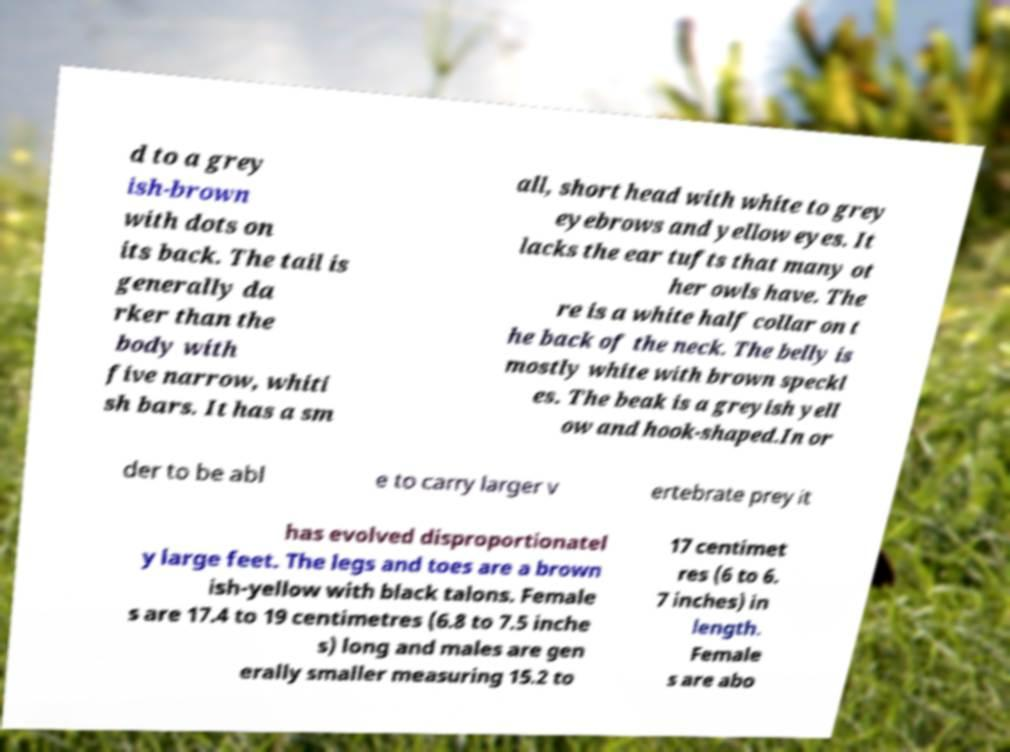There's text embedded in this image that I need extracted. Can you transcribe it verbatim? d to a grey ish-brown with dots on its back. The tail is generally da rker than the body with five narrow, whiti sh bars. It has a sm all, short head with white to grey eyebrows and yellow eyes. It lacks the ear tufts that many ot her owls have. The re is a white half collar on t he back of the neck. The belly is mostly white with brown speckl es. The beak is a greyish yell ow and hook-shaped.In or der to be abl e to carry larger v ertebrate prey it has evolved disproportionatel y large feet. The legs and toes are a brown ish-yellow with black talons. Female s are 17.4 to 19 centimetres (6.8 to 7.5 inche s) long and males are gen erally smaller measuring 15.2 to 17 centimet res (6 to 6. 7 inches) in length. Female s are abo 